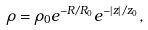<formula> <loc_0><loc_0><loc_500><loc_500>\rho = \rho _ { 0 } e ^ { - R / R _ { 0 } } e ^ { - \left | z \right | / z _ { 0 } } ,</formula> 